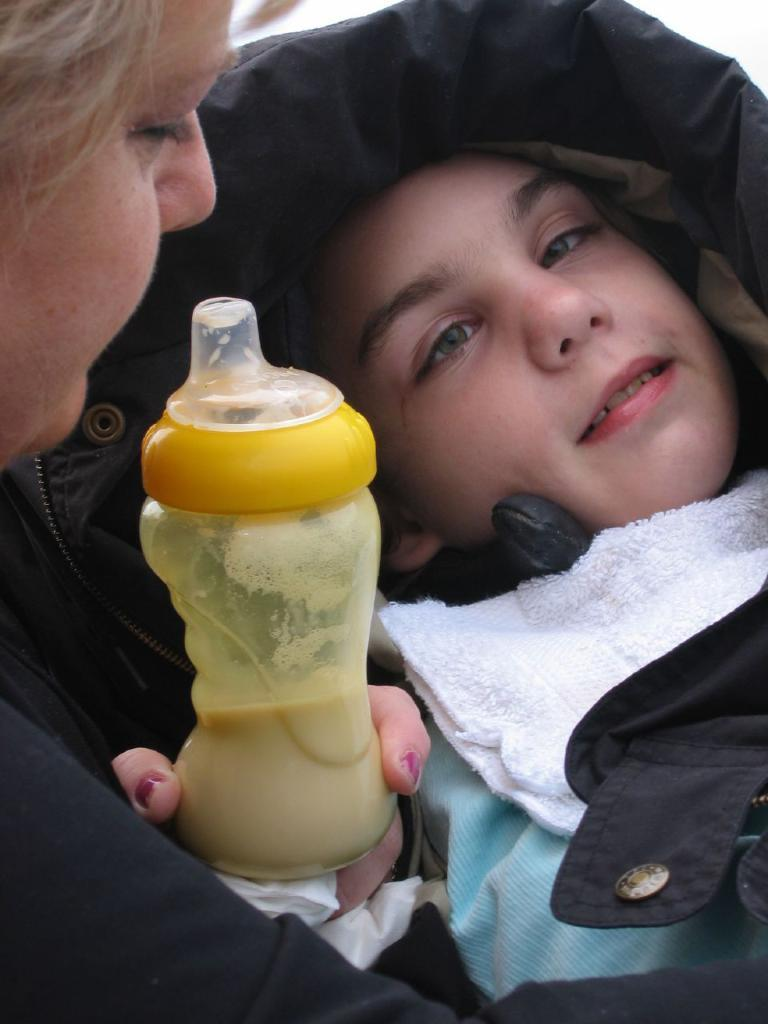Who is present in the image? There is a boy and a woman in the image. What is the boy doing in the image? The boy is sleeping. What is the woman doing in the image? The woman is sitting. What is the woman holding in her hand? The woman is holding a milk bottle in her hand. What type of business is the woman conducting in the image? There is no indication of a business in the image; the woman is simply sitting and holding a milk bottle. 